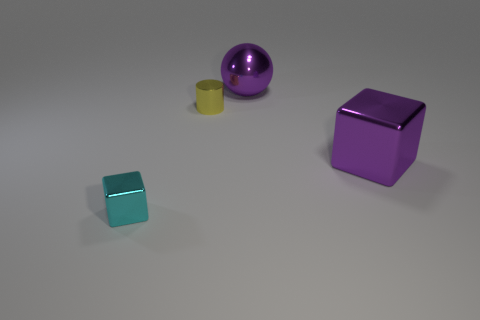What number of objects are on the right side of the tiny metallic thing that is in front of the big shiny thing to the right of the metal sphere?
Offer a terse response. 3. What is the size of the shiny cube behind the small cyan thing?
Offer a very short reply. Large. How many yellow metallic objects have the same size as the purple ball?
Provide a succinct answer. 0. There is a yellow object; is it the same size as the cube that is behind the tiny cyan block?
Ensure brevity in your answer.  No. What number of objects are either tiny brown cylinders or tiny metal things?
Provide a succinct answer. 2. What number of other cubes have the same color as the large cube?
Make the answer very short. 0. There is a cyan thing that is the same size as the metallic cylinder; what is its shape?
Give a very brief answer. Cube. Are there any other cyan shiny things that have the same shape as the cyan object?
Keep it short and to the point. No. What number of big purple objects have the same material as the large purple sphere?
Offer a terse response. 1. Is the material of the large purple object that is behind the small cylinder the same as the yellow object?
Your answer should be very brief. Yes. 